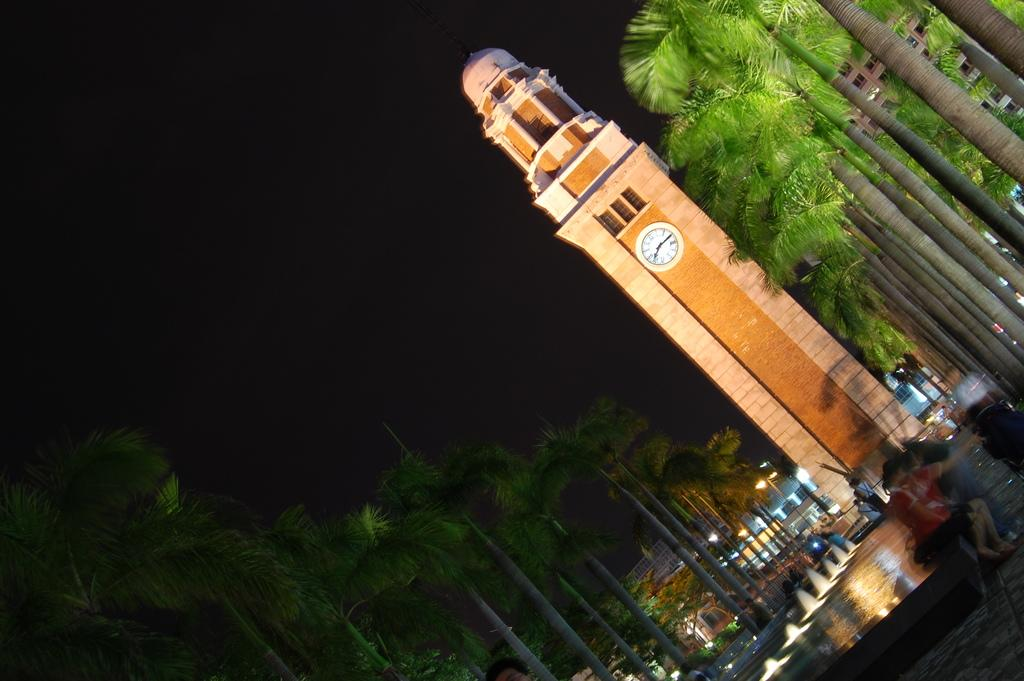What is the main structure in the image? There is a big clock tower in the image. What can be seen behind the clock tower? There is a building behind the clock tower. What is in front of the clock tower? There is a road in front of the clock tower. What is happening on the road? There are people standing on the road. What type of vegetation is beside the road? There are trees beside the road. What type of copper material is used to make the farm in the image? There is no farm present in the image, and therefore no copper material can be identified. Can you see any windows on the clock tower in the image? The image does not show any windows on the clock tower. 